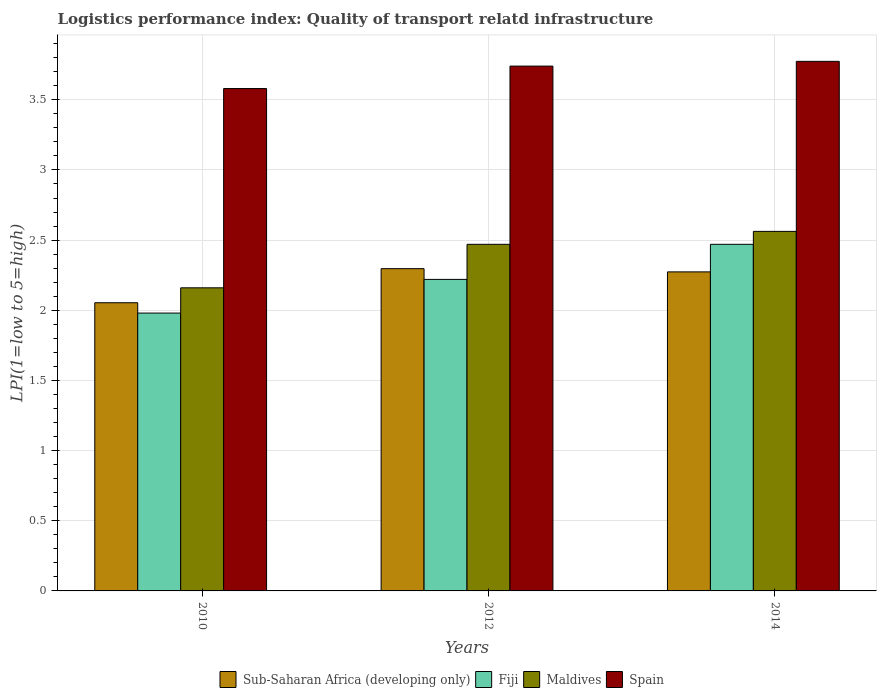How many groups of bars are there?
Provide a short and direct response. 3. Are the number of bars per tick equal to the number of legend labels?
Your response must be concise. Yes. Are the number of bars on each tick of the X-axis equal?
Your answer should be very brief. Yes. How many bars are there on the 3rd tick from the left?
Keep it short and to the point. 4. What is the label of the 2nd group of bars from the left?
Your answer should be compact. 2012. What is the logistics performance index in Fiji in 2014?
Provide a succinct answer. 2.47. Across all years, what is the maximum logistics performance index in Spain?
Make the answer very short. 3.77. Across all years, what is the minimum logistics performance index in Maldives?
Your answer should be compact. 2.16. In which year was the logistics performance index in Fiji minimum?
Your response must be concise. 2010. What is the total logistics performance index in Sub-Saharan Africa (developing only) in the graph?
Offer a very short reply. 6.62. What is the difference between the logistics performance index in Sub-Saharan Africa (developing only) in 2010 and that in 2014?
Ensure brevity in your answer.  -0.22. What is the difference between the logistics performance index in Spain in 2014 and the logistics performance index in Maldives in 2012?
Offer a terse response. 1.3. What is the average logistics performance index in Spain per year?
Your response must be concise. 3.7. In the year 2012, what is the difference between the logistics performance index in Spain and logistics performance index in Maldives?
Keep it short and to the point. 1.27. What is the ratio of the logistics performance index in Fiji in 2010 to that in 2012?
Your answer should be very brief. 0.89. Is the logistics performance index in Fiji in 2010 less than that in 2014?
Provide a succinct answer. Yes. Is the difference between the logistics performance index in Spain in 2012 and 2014 greater than the difference between the logistics performance index in Maldives in 2012 and 2014?
Provide a short and direct response. Yes. What is the difference between the highest and the second highest logistics performance index in Sub-Saharan Africa (developing only)?
Your answer should be very brief. 0.02. What is the difference between the highest and the lowest logistics performance index in Fiji?
Provide a succinct answer. 0.49. In how many years, is the logistics performance index in Fiji greater than the average logistics performance index in Fiji taken over all years?
Offer a very short reply. 1. What does the 4th bar from the left in 2014 represents?
Offer a terse response. Spain. What does the 2nd bar from the right in 2010 represents?
Make the answer very short. Maldives. Are all the bars in the graph horizontal?
Your answer should be very brief. No. Are the values on the major ticks of Y-axis written in scientific E-notation?
Keep it short and to the point. No. Does the graph contain any zero values?
Give a very brief answer. No. What is the title of the graph?
Keep it short and to the point. Logistics performance index: Quality of transport relatd infrastructure. What is the label or title of the X-axis?
Give a very brief answer. Years. What is the label or title of the Y-axis?
Give a very brief answer. LPI(1=low to 5=high). What is the LPI(1=low to 5=high) in Sub-Saharan Africa (developing only) in 2010?
Offer a terse response. 2.05. What is the LPI(1=low to 5=high) in Fiji in 2010?
Provide a succinct answer. 1.98. What is the LPI(1=low to 5=high) of Maldives in 2010?
Make the answer very short. 2.16. What is the LPI(1=low to 5=high) of Spain in 2010?
Give a very brief answer. 3.58. What is the LPI(1=low to 5=high) of Sub-Saharan Africa (developing only) in 2012?
Your response must be concise. 2.3. What is the LPI(1=low to 5=high) in Fiji in 2012?
Offer a very short reply. 2.22. What is the LPI(1=low to 5=high) of Maldives in 2012?
Your answer should be compact. 2.47. What is the LPI(1=low to 5=high) of Spain in 2012?
Keep it short and to the point. 3.74. What is the LPI(1=low to 5=high) in Sub-Saharan Africa (developing only) in 2014?
Provide a succinct answer. 2.27. What is the LPI(1=low to 5=high) of Fiji in 2014?
Your response must be concise. 2.47. What is the LPI(1=low to 5=high) in Maldives in 2014?
Your response must be concise. 2.56. What is the LPI(1=low to 5=high) in Spain in 2014?
Your answer should be very brief. 3.77. Across all years, what is the maximum LPI(1=low to 5=high) in Sub-Saharan Africa (developing only)?
Ensure brevity in your answer.  2.3. Across all years, what is the maximum LPI(1=low to 5=high) of Fiji?
Ensure brevity in your answer.  2.47. Across all years, what is the maximum LPI(1=low to 5=high) of Maldives?
Offer a very short reply. 2.56. Across all years, what is the maximum LPI(1=low to 5=high) in Spain?
Provide a short and direct response. 3.77. Across all years, what is the minimum LPI(1=low to 5=high) of Sub-Saharan Africa (developing only)?
Offer a terse response. 2.05. Across all years, what is the minimum LPI(1=low to 5=high) in Fiji?
Your answer should be compact. 1.98. Across all years, what is the minimum LPI(1=low to 5=high) in Maldives?
Offer a very short reply. 2.16. Across all years, what is the minimum LPI(1=low to 5=high) of Spain?
Your response must be concise. 3.58. What is the total LPI(1=low to 5=high) of Sub-Saharan Africa (developing only) in the graph?
Offer a terse response. 6.62. What is the total LPI(1=low to 5=high) of Fiji in the graph?
Give a very brief answer. 6.67. What is the total LPI(1=low to 5=high) of Maldives in the graph?
Provide a succinct answer. 7.19. What is the total LPI(1=low to 5=high) in Spain in the graph?
Make the answer very short. 11.09. What is the difference between the LPI(1=low to 5=high) of Sub-Saharan Africa (developing only) in 2010 and that in 2012?
Provide a succinct answer. -0.24. What is the difference between the LPI(1=low to 5=high) of Fiji in 2010 and that in 2012?
Ensure brevity in your answer.  -0.24. What is the difference between the LPI(1=low to 5=high) in Maldives in 2010 and that in 2012?
Your response must be concise. -0.31. What is the difference between the LPI(1=low to 5=high) in Spain in 2010 and that in 2012?
Your answer should be compact. -0.16. What is the difference between the LPI(1=low to 5=high) of Sub-Saharan Africa (developing only) in 2010 and that in 2014?
Keep it short and to the point. -0.22. What is the difference between the LPI(1=low to 5=high) of Fiji in 2010 and that in 2014?
Ensure brevity in your answer.  -0.49. What is the difference between the LPI(1=low to 5=high) of Maldives in 2010 and that in 2014?
Provide a succinct answer. -0.4. What is the difference between the LPI(1=low to 5=high) of Spain in 2010 and that in 2014?
Provide a short and direct response. -0.19. What is the difference between the LPI(1=low to 5=high) of Sub-Saharan Africa (developing only) in 2012 and that in 2014?
Ensure brevity in your answer.  0.02. What is the difference between the LPI(1=low to 5=high) of Maldives in 2012 and that in 2014?
Make the answer very short. -0.09. What is the difference between the LPI(1=low to 5=high) in Spain in 2012 and that in 2014?
Provide a short and direct response. -0.03. What is the difference between the LPI(1=low to 5=high) of Sub-Saharan Africa (developing only) in 2010 and the LPI(1=low to 5=high) of Fiji in 2012?
Your answer should be compact. -0.17. What is the difference between the LPI(1=low to 5=high) in Sub-Saharan Africa (developing only) in 2010 and the LPI(1=low to 5=high) in Maldives in 2012?
Keep it short and to the point. -0.42. What is the difference between the LPI(1=low to 5=high) of Sub-Saharan Africa (developing only) in 2010 and the LPI(1=low to 5=high) of Spain in 2012?
Your response must be concise. -1.69. What is the difference between the LPI(1=low to 5=high) of Fiji in 2010 and the LPI(1=low to 5=high) of Maldives in 2012?
Give a very brief answer. -0.49. What is the difference between the LPI(1=low to 5=high) in Fiji in 2010 and the LPI(1=low to 5=high) in Spain in 2012?
Provide a short and direct response. -1.76. What is the difference between the LPI(1=low to 5=high) of Maldives in 2010 and the LPI(1=low to 5=high) of Spain in 2012?
Offer a very short reply. -1.58. What is the difference between the LPI(1=low to 5=high) in Sub-Saharan Africa (developing only) in 2010 and the LPI(1=low to 5=high) in Fiji in 2014?
Your response must be concise. -0.42. What is the difference between the LPI(1=low to 5=high) in Sub-Saharan Africa (developing only) in 2010 and the LPI(1=low to 5=high) in Maldives in 2014?
Offer a very short reply. -0.51. What is the difference between the LPI(1=low to 5=high) in Sub-Saharan Africa (developing only) in 2010 and the LPI(1=low to 5=high) in Spain in 2014?
Offer a terse response. -1.72. What is the difference between the LPI(1=low to 5=high) of Fiji in 2010 and the LPI(1=low to 5=high) of Maldives in 2014?
Offer a very short reply. -0.58. What is the difference between the LPI(1=low to 5=high) of Fiji in 2010 and the LPI(1=low to 5=high) of Spain in 2014?
Offer a very short reply. -1.79. What is the difference between the LPI(1=low to 5=high) of Maldives in 2010 and the LPI(1=low to 5=high) of Spain in 2014?
Keep it short and to the point. -1.61. What is the difference between the LPI(1=low to 5=high) of Sub-Saharan Africa (developing only) in 2012 and the LPI(1=low to 5=high) of Fiji in 2014?
Offer a terse response. -0.17. What is the difference between the LPI(1=low to 5=high) in Sub-Saharan Africa (developing only) in 2012 and the LPI(1=low to 5=high) in Maldives in 2014?
Ensure brevity in your answer.  -0.27. What is the difference between the LPI(1=low to 5=high) of Sub-Saharan Africa (developing only) in 2012 and the LPI(1=low to 5=high) of Spain in 2014?
Make the answer very short. -1.48. What is the difference between the LPI(1=low to 5=high) of Fiji in 2012 and the LPI(1=low to 5=high) of Maldives in 2014?
Give a very brief answer. -0.34. What is the difference between the LPI(1=low to 5=high) in Fiji in 2012 and the LPI(1=low to 5=high) in Spain in 2014?
Provide a succinct answer. -1.55. What is the difference between the LPI(1=low to 5=high) in Maldives in 2012 and the LPI(1=low to 5=high) in Spain in 2014?
Provide a succinct answer. -1.3. What is the average LPI(1=low to 5=high) of Sub-Saharan Africa (developing only) per year?
Your response must be concise. 2.21. What is the average LPI(1=low to 5=high) of Fiji per year?
Provide a short and direct response. 2.22. What is the average LPI(1=low to 5=high) of Maldives per year?
Give a very brief answer. 2.4. What is the average LPI(1=low to 5=high) of Spain per year?
Keep it short and to the point. 3.7. In the year 2010, what is the difference between the LPI(1=low to 5=high) of Sub-Saharan Africa (developing only) and LPI(1=low to 5=high) of Fiji?
Give a very brief answer. 0.07. In the year 2010, what is the difference between the LPI(1=low to 5=high) in Sub-Saharan Africa (developing only) and LPI(1=low to 5=high) in Maldives?
Give a very brief answer. -0.11. In the year 2010, what is the difference between the LPI(1=low to 5=high) in Sub-Saharan Africa (developing only) and LPI(1=low to 5=high) in Spain?
Give a very brief answer. -1.53. In the year 2010, what is the difference between the LPI(1=low to 5=high) in Fiji and LPI(1=low to 5=high) in Maldives?
Provide a short and direct response. -0.18. In the year 2010, what is the difference between the LPI(1=low to 5=high) in Fiji and LPI(1=low to 5=high) in Spain?
Offer a very short reply. -1.6. In the year 2010, what is the difference between the LPI(1=low to 5=high) of Maldives and LPI(1=low to 5=high) of Spain?
Provide a succinct answer. -1.42. In the year 2012, what is the difference between the LPI(1=low to 5=high) of Sub-Saharan Africa (developing only) and LPI(1=low to 5=high) of Fiji?
Offer a terse response. 0.08. In the year 2012, what is the difference between the LPI(1=low to 5=high) of Sub-Saharan Africa (developing only) and LPI(1=low to 5=high) of Maldives?
Keep it short and to the point. -0.17. In the year 2012, what is the difference between the LPI(1=low to 5=high) in Sub-Saharan Africa (developing only) and LPI(1=low to 5=high) in Spain?
Your answer should be very brief. -1.44. In the year 2012, what is the difference between the LPI(1=low to 5=high) in Fiji and LPI(1=low to 5=high) in Maldives?
Provide a succinct answer. -0.25. In the year 2012, what is the difference between the LPI(1=low to 5=high) of Fiji and LPI(1=low to 5=high) of Spain?
Give a very brief answer. -1.52. In the year 2012, what is the difference between the LPI(1=low to 5=high) of Maldives and LPI(1=low to 5=high) of Spain?
Keep it short and to the point. -1.27. In the year 2014, what is the difference between the LPI(1=low to 5=high) of Sub-Saharan Africa (developing only) and LPI(1=low to 5=high) of Fiji?
Your response must be concise. -0.2. In the year 2014, what is the difference between the LPI(1=low to 5=high) in Sub-Saharan Africa (developing only) and LPI(1=low to 5=high) in Maldives?
Make the answer very short. -0.29. In the year 2014, what is the difference between the LPI(1=low to 5=high) of Sub-Saharan Africa (developing only) and LPI(1=low to 5=high) of Spain?
Keep it short and to the point. -1.5. In the year 2014, what is the difference between the LPI(1=low to 5=high) in Fiji and LPI(1=low to 5=high) in Maldives?
Offer a terse response. -0.09. In the year 2014, what is the difference between the LPI(1=low to 5=high) of Fiji and LPI(1=low to 5=high) of Spain?
Keep it short and to the point. -1.3. In the year 2014, what is the difference between the LPI(1=low to 5=high) in Maldives and LPI(1=low to 5=high) in Spain?
Your answer should be very brief. -1.21. What is the ratio of the LPI(1=low to 5=high) in Sub-Saharan Africa (developing only) in 2010 to that in 2012?
Make the answer very short. 0.89. What is the ratio of the LPI(1=low to 5=high) of Fiji in 2010 to that in 2012?
Your response must be concise. 0.89. What is the ratio of the LPI(1=low to 5=high) in Maldives in 2010 to that in 2012?
Your answer should be very brief. 0.87. What is the ratio of the LPI(1=low to 5=high) of Spain in 2010 to that in 2012?
Offer a very short reply. 0.96. What is the ratio of the LPI(1=low to 5=high) in Sub-Saharan Africa (developing only) in 2010 to that in 2014?
Provide a succinct answer. 0.9. What is the ratio of the LPI(1=low to 5=high) of Fiji in 2010 to that in 2014?
Your response must be concise. 0.8. What is the ratio of the LPI(1=low to 5=high) of Maldives in 2010 to that in 2014?
Ensure brevity in your answer.  0.84. What is the ratio of the LPI(1=low to 5=high) of Spain in 2010 to that in 2014?
Ensure brevity in your answer.  0.95. What is the ratio of the LPI(1=low to 5=high) of Fiji in 2012 to that in 2014?
Your answer should be compact. 0.9. What is the ratio of the LPI(1=low to 5=high) of Spain in 2012 to that in 2014?
Your response must be concise. 0.99. What is the difference between the highest and the second highest LPI(1=low to 5=high) of Sub-Saharan Africa (developing only)?
Offer a very short reply. 0.02. What is the difference between the highest and the second highest LPI(1=low to 5=high) of Fiji?
Offer a terse response. 0.25. What is the difference between the highest and the second highest LPI(1=low to 5=high) of Maldives?
Offer a terse response. 0.09. What is the difference between the highest and the second highest LPI(1=low to 5=high) in Spain?
Your response must be concise. 0.03. What is the difference between the highest and the lowest LPI(1=low to 5=high) of Sub-Saharan Africa (developing only)?
Provide a succinct answer. 0.24. What is the difference between the highest and the lowest LPI(1=low to 5=high) in Fiji?
Offer a very short reply. 0.49. What is the difference between the highest and the lowest LPI(1=low to 5=high) of Maldives?
Give a very brief answer. 0.4. What is the difference between the highest and the lowest LPI(1=low to 5=high) in Spain?
Keep it short and to the point. 0.19. 